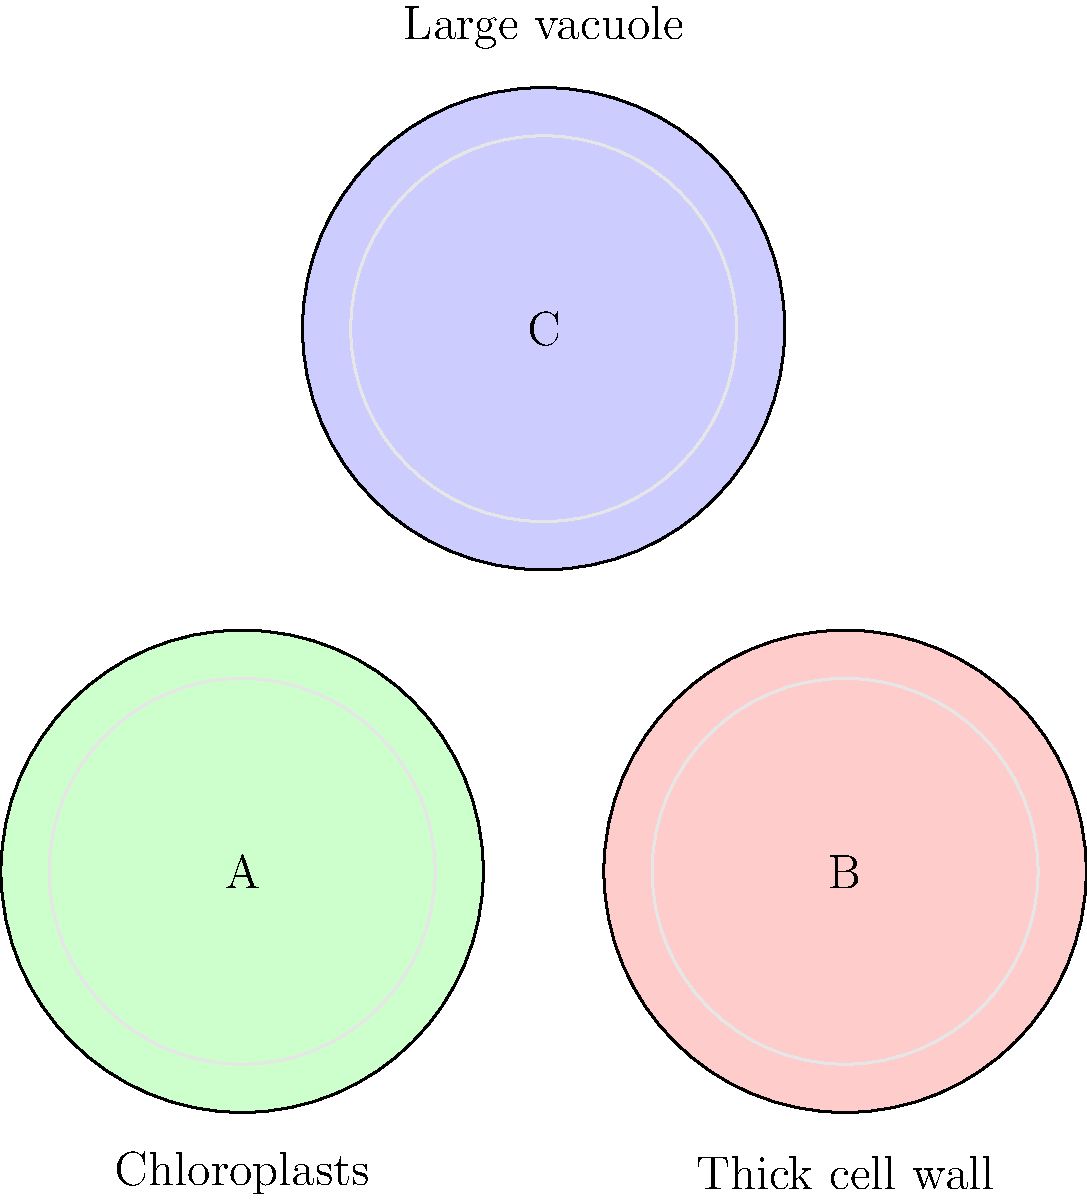In the microscope images above, which cell is most likely to be a guard cell found in the epidermis of a leaf? To identify the guard cell, we need to consider the characteristics of different plant cell types:

1. Cell A: Shows chloroplasts, which are typical in photosynthetic cells.
2. Cell B: Has a thick cell wall, often found in structural cells like xylem or sclerenchyma.
3. Cell C: Displays a large vacuole, common in many plant cells, especially parenchyma.

Guard cells have specific features:
- They contain chloroplasts for photosynthesis.
- They have a relatively thin cell wall that can change shape.
- They don't typically have an extremely large vacuole.

Comparing these characteristics to our images:
- Cell A matches the guard cell description best, with visible chloroplasts and no indication of a thick cell wall or oversized vacuole.
- Cell B's thick cell wall is not characteristic of guard cells.
- Cell C's large vacuole is more typical of other epidermal cells or parenchyma cells.

Therefore, Cell A is most likely to be a guard cell.
Answer: Cell A 